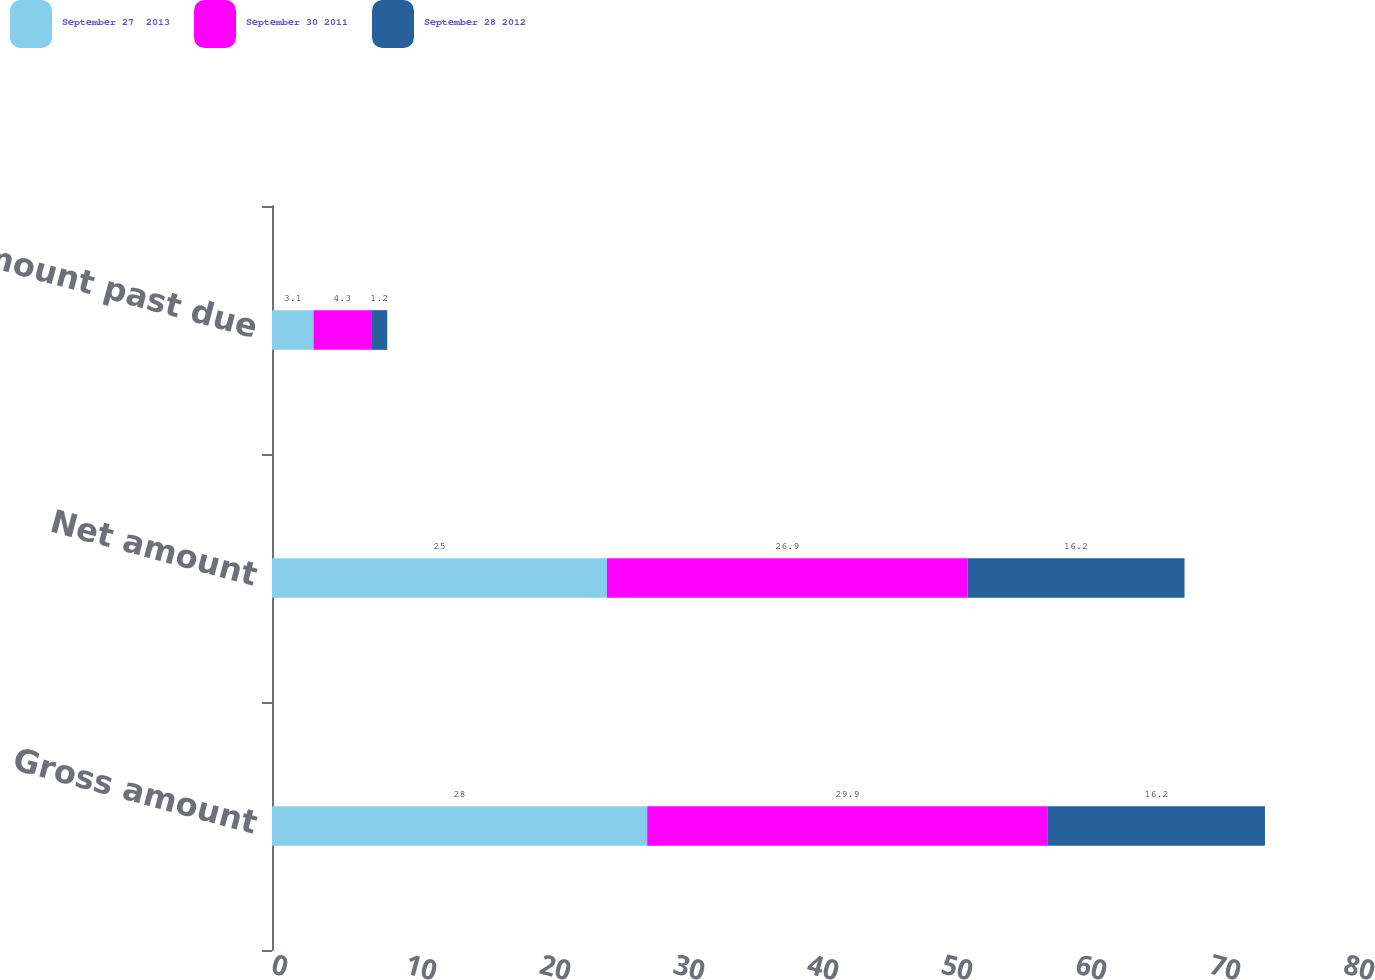Convert chart. <chart><loc_0><loc_0><loc_500><loc_500><stacked_bar_chart><ecel><fcel>Gross amount<fcel>Net amount<fcel>Amount past due<nl><fcel>September 27  2013<fcel>28<fcel>25<fcel>3.1<nl><fcel>September 30 2011<fcel>29.9<fcel>26.9<fcel>4.3<nl><fcel>September 28 2012<fcel>16.2<fcel>16.2<fcel>1.2<nl></chart> 